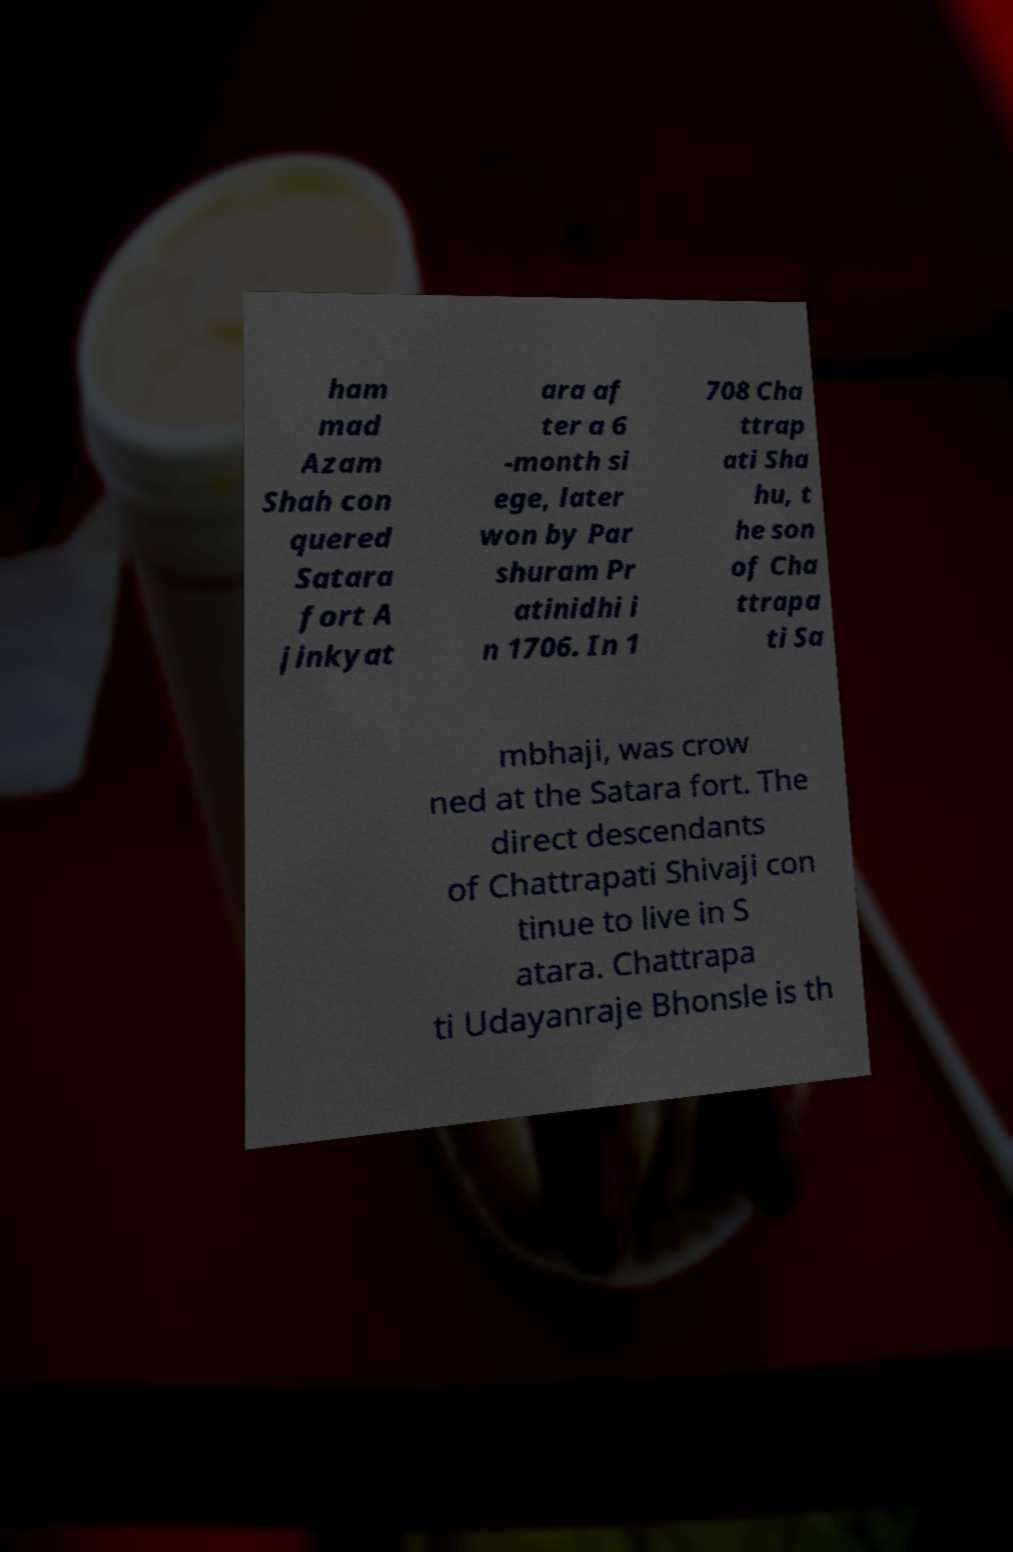I need the written content from this picture converted into text. Can you do that? ham mad Azam Shah con quered Satara fort A jinkyat ara af ter a 6 -month si ege, later won by Par shuram Pr atinidhi i n 1706. In 1 708 Cha ttrap ati Sha hu, t he son of Cha ttrapa ti Sa mbhaji, was crow ned at the Satara fort. The direct descendants of Chattrapati Shivaji con tinue to live in S atara. Chattrapa ti Udayanraje Bhonsle is th 